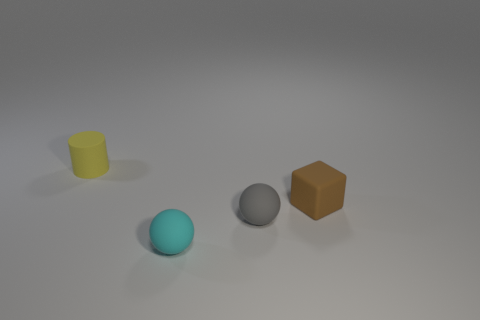The matte cylinder has what color?
Your answer should be very brief. Yellow. What number of other tiny objects have the same shape as the small yellow rubber object?
Provide a succinct answer. 0. There is a cyan sphere that is the same size as the matte cylinder; what is its material?
Your answer should be compact. Rubber. Are there any yellow objects that have the same material as the small cyan thing?
Provide a succinct answer. Yes. What color is the tiny rubber ball that is behind the matte ball that is in front of the small rubber ball that is behind the cyan thing?
Your answer should be compact. Gray. Is the number of cylinders on the right side of the cyan thing less than the number of tiny cubes?
Your answer should be compact. Yes. How many tiny yellow matte objects are there?
Give a very brief answer. 1. There is a cyan object; is its shape the same as the gray matte object that is to the right of the tiny cyan rubber sphere?
Ensure brevity in your answer.  Yes. Are there fewer tiny yellow matte cylinders in front of the small gray matte sphere than rubber objects that are to the left of the cyan rubber thing?
Offer a terse response. Yes. Are there any other things that are the same shape as the yellow matte object?
Keep it short and to the point. No. 